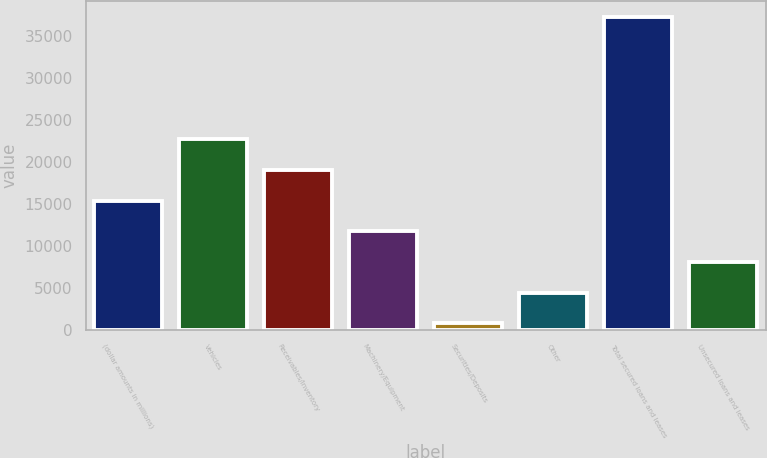Convert chart to OTSL. <chart><loc_0><loc_0><loc_500><loc_500><bar_chart><fcel>(dollar amounts in millions)<fcel>Vehicles<fcel>Receivables/Inventory<fcel>Machinery/Equipment<fcel>Securities/Deposits<fcel>Other<fcel>Total secured loans and leases<fcel>Unsecured loans and leases<nl><fcel>15393.6<fcel>22690.4<fcel>19042<fcel>11745.2<fcel>800<fcel>4448.4<fcel>37284<fcel>8096.8<nl></chart> 